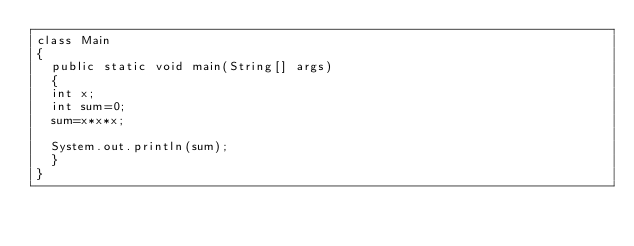<code> <loc_0><loc_0><loc_500><loc_500><_Java_>class Main
{
	public static void main(String[] args)
	{
	int x;
	int sum=0;
	sum=x*x*x;
	
	System.out.println(sum);
	}
}</code> 